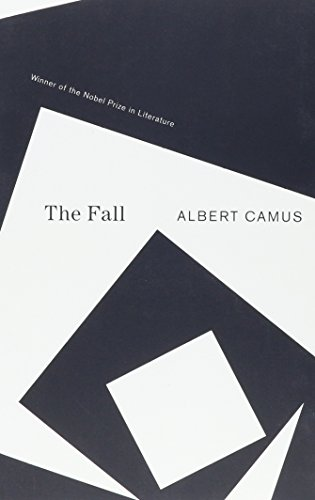Who wrote this book?
Answer the question using a single word or phrase. Albert Camus What is the title of this book? The Fall What type of book is this? Literature & Fiction Is this book related to Literature & Fiction? Yes Is this book related to Science Fiction & Fantasy? No 